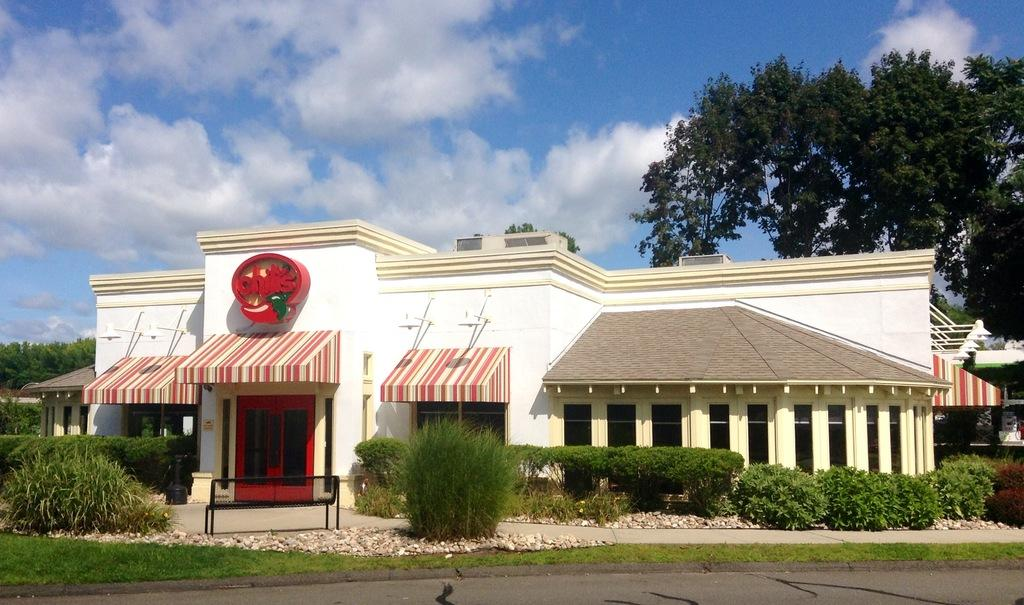Provide a one-sentence caption for the provided image. A Chili's restaurant has striped awnings and a red sign.. 